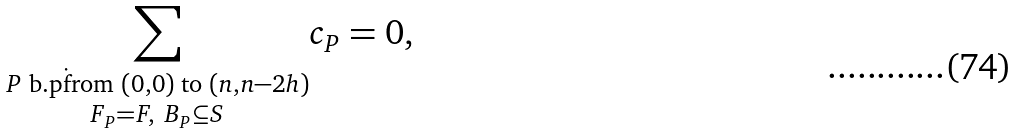<formula> <loc_0><loc_0><loc_500><loc_500>\underset { F _ { P } = F , \ B _ { P } \subseteq S } { \sum _ { P \text { b.p\. from } ( 0 , 0 ) \text { to } ( n , n - 2 h ) } } c _ { P } = 0 ,</formula> 